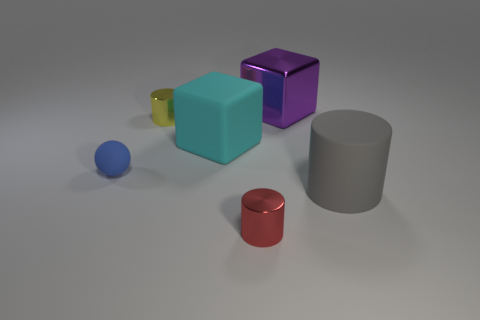Add 4 rubber cylinders. How many objects exist? 10 Subtract all blocks. How many objects are left? 4 Add 2 yellow objects. How many yellow objects are left? 3 Add 2 metallic blocks. How many metallic blocks exist? 3 Subtract 1 red cylinders. How many objects are left? 5 Subtract all cyan shiny spheres. Subtract all blue rubber objects. How many objects are left? 5 